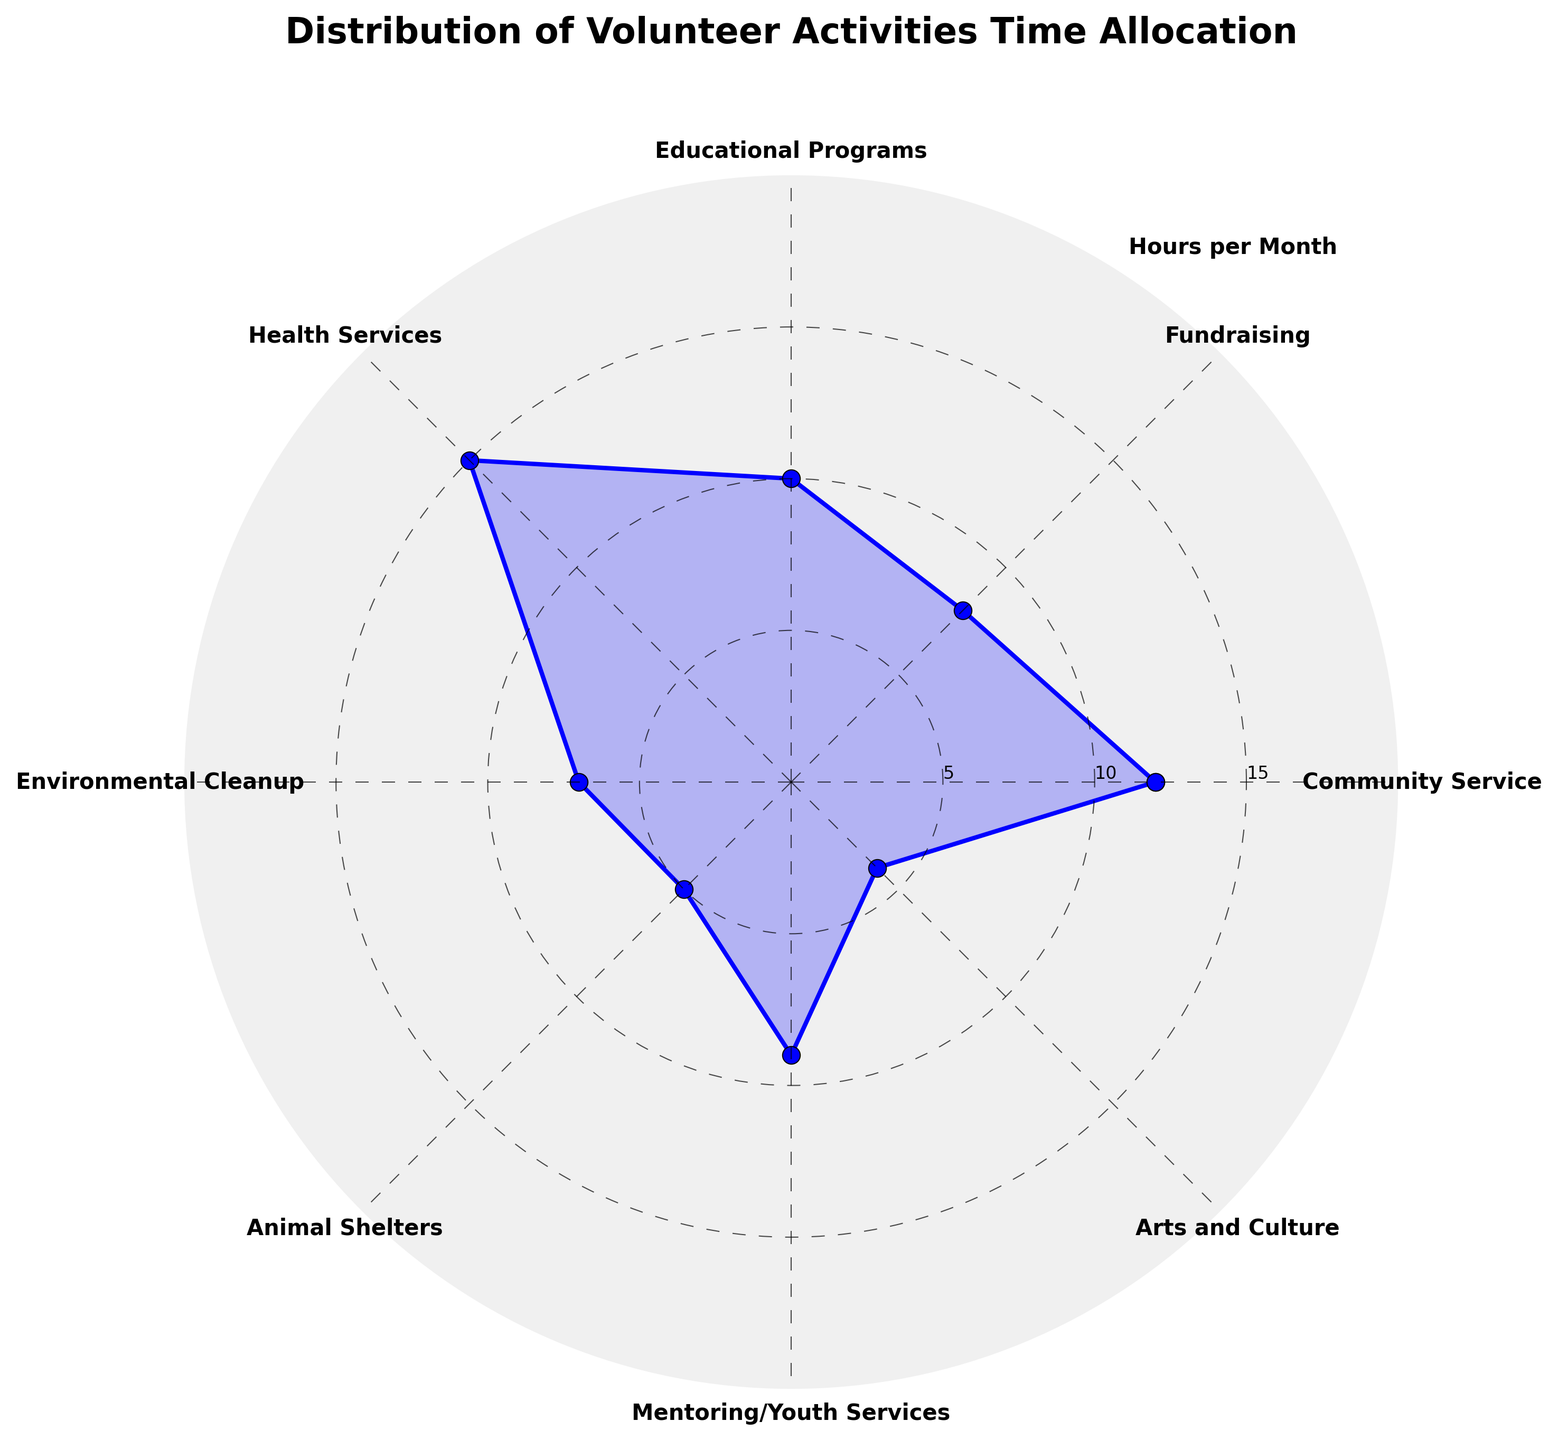what is the category with the highest time allocation? The category with the highest time allocation can be found by looking for the highest point on the radial axis. In this chart, the highest point is at 15 hours.
Answer: Health Services how many categories allocate more than 10 hours per month? To find the categories that allocate more than 10 hours per month, look for data points that extend beyond the 10-hour radial mark. The categories highly educational programs and health services.
Answer: 2 Which category dedicates fewer hours, Animal Shelters or Arts and Culture? By comparing the radial distances of Animal Shelters and Arts and Culture, we see that Arts and Culture has a radial distance corresponding to 4 hours, and Animal Shelters has a distance of 5 hours. Therefore, Arts and Culture dedicates fewer hours.
Answer: Arts and Culture What is the total time allocation for the top three categories with the highest hours per month? The top three categories are Health Services (15), Community Service (12), and Educational Programs (10). Summing these gives 15 + 12 + 10 = 37 hours.
Answer: 37 hours What is the average time allocated per month across all categories? Sum all the hours: 12 + 8 + 10 + 15 + 7 + 5 + 9 + 4 = 70 hours. There are 8 categories, so the average is 70 / 8 = 8.75 hours.
Answer: 8.75 hours Which categories allocate fewer hours compared to fundraising? Fundraising allocates 8 hours per month. Categories that allocate less are Animal Shelters (5), Environmental Cleanup (7), and Arts and Culture (4).
Answer: 3 categories If we increase each category’s hours by 25%, how many categories would then exceed 10 hours per month? Increasing hours by 25%, we get Community Service (15), Fundraising (10), Education Programs (12.5), Health Services (18.75), Environmental Cleanup (8.75), Animal Shelters (6.25), Mentoring/Youth Services (11.25), and Arts and Culture (5). Categories exceeding 10 hours are Community Service, Educational Programs, Health Services, and Mentoring/Youth Services.
Answer: 4 categories 